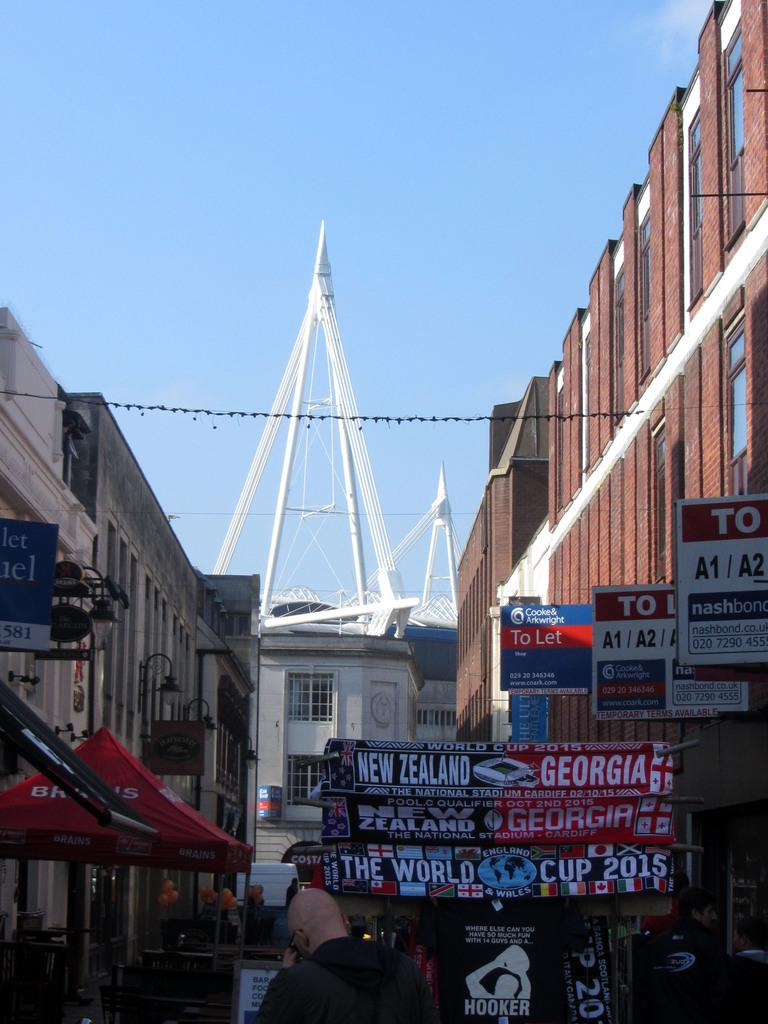Who or what can be seen in the image? There are people in the image. What is written on the banners in the image? There are banners with writing in the image. What type of lighting is present in the image? Street lights are visible in the image. What is attached to the buildings in the image? There are boards attached to buildings in the image. What can be seen in the background of the image? The sky is visible in the background of the image. How many basins are visible in the image? There are no basins present in the image. 